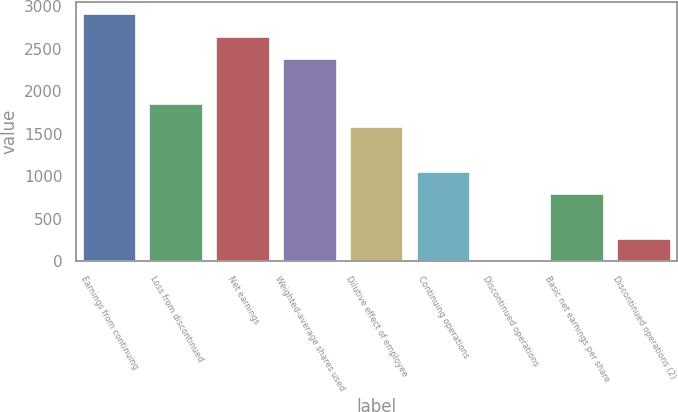Convert chart to OTSL. <chart><loc_0><loc_0><loc_500><loc_500><bar_chart><fcel>Earnings from continuing<fcel>Loss from discontinued<fcel>Net earnings<fcel>Weighted-average shares used<fcel>Dilutive effect of employee<fcel>Continuing operations<fcel>Discontinued operations<fcel>Basic net earnings per share<fcel>Discontinued operations (2)<nl><fcel>2903.99<fcel>1848.03<fcel>2640<fcel>2376.01<fcel>1584.04<fcel>1056.06<fcel>0.1<fcel>792.07<fcel>264.09<nl></chart> 